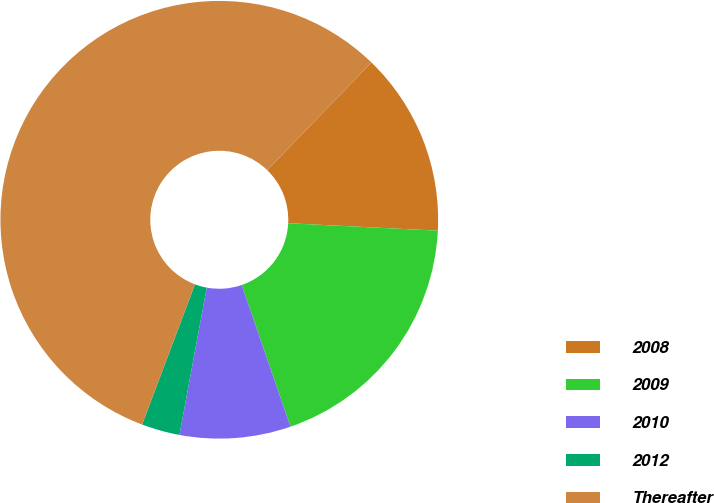Convert chart. <chart><loc_0><loc_0><loc_500><loc_500><pie_chart><fcel>2008<fcel>2009<fcel>2010<fcel>2012<fcel>Thereafter<nl><fcel>13.56%<fcel>18.93%<fcel>8.19%<fcel>2.82%<fcel>56.5%<nl></chart> 